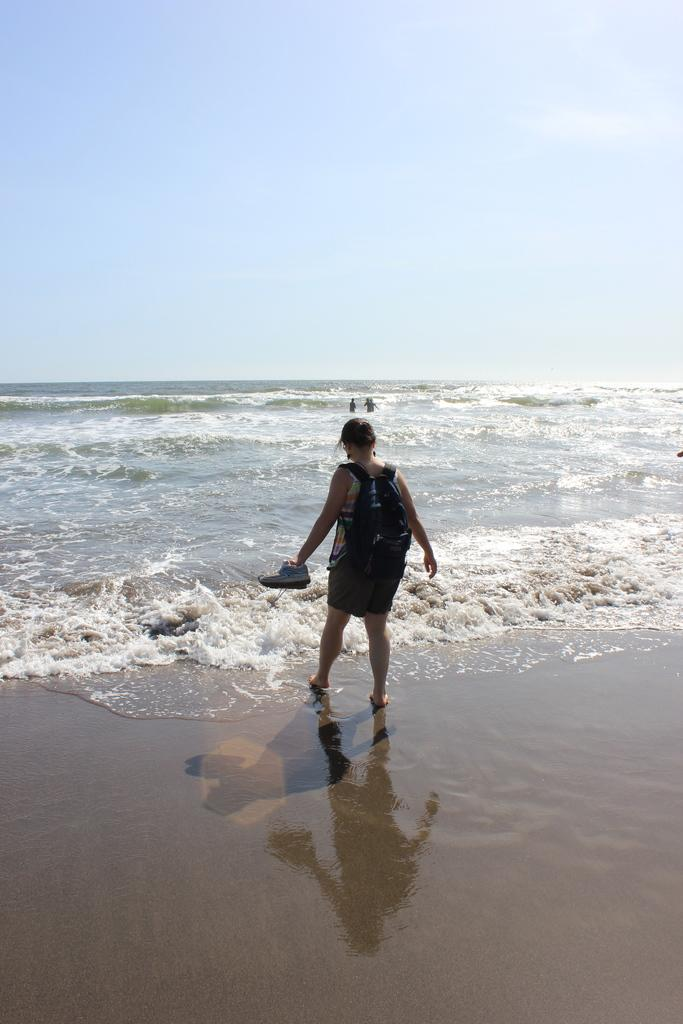What is present in the image? There is a person in the image. What is the person wearing? The person is wearing a bag. What is the person holding? The person is holding footwear. What can be seen in the background of the image? The sky is visible in the background of the image. Is there any water visible in the image? Yes, there is water visible in the image. What type of stem can be seen growing from the person's head in the image? There is no stem growing from the person's head in the image. 